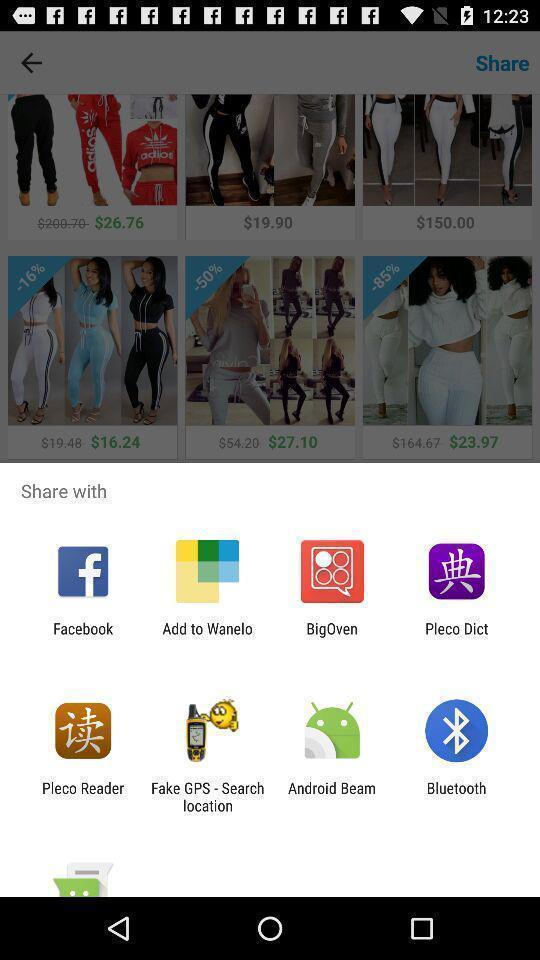Give me a narrative description of this picture. Push up page showing app preference to share. 